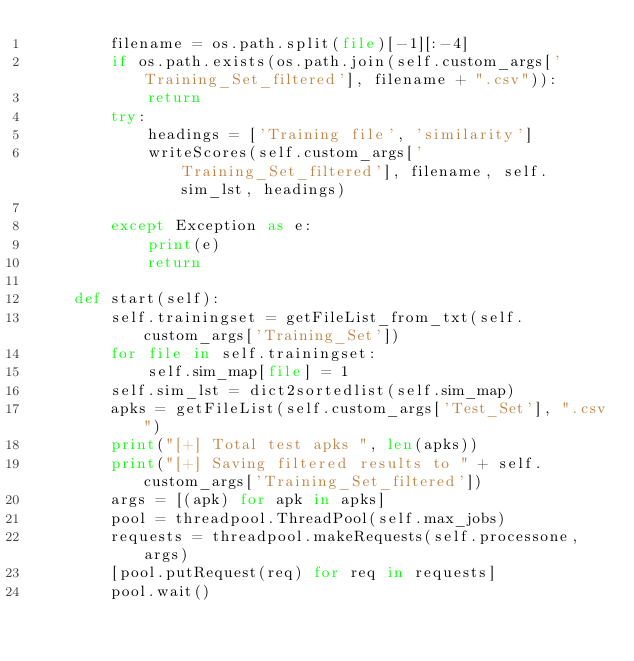<code> <loc_0><loc_0><loc_500><loc_500><_Python_>        filename = os.path.split(file)[-1][:-4]
        if os.path.exists(os.path.join(self.custom_args['Training_Set_filtered'], filename + ".csv")):
            return
        try:
            headings = ['Training file', 'similarity']
            writeScores(self.custom_args['Training_Set_filtered'], filename, self.sim_lst, headings)

        except Exception as e:
            print(e)
            return

    def start(self):
        self.trainingset = getFileList_from_txt(self.custom_args['Training_Set'])
        for file in self.trainingset:
            self.sim_map[file] = 1
        self.sim_lst = dict2sortedlist(self.sim_map)
        apks = getFileList(self.custom_args['Test_Set'], ".csv")
        print("[+] Total test apks ", len(apks))
        print("[+] Saving filtered results to " + self.custom_args['Training_Set_filtered'])
        args = [(apk) for apk in apks]
        pool = threadpool.ThreadPool(self.max_jobs)
        requests = threadpool.makeRequests(self.processone, args)
        [pool.putRequest(req) for req in requests]
        pool.wait()

</code> 